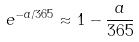Convert formula to latex. <formula><loc_0><loc_0><loc_500><loc_500>e ^ { - a / 3 6 5 } \approx 1 - \frac { a } { 3 6 5 }</formula> 